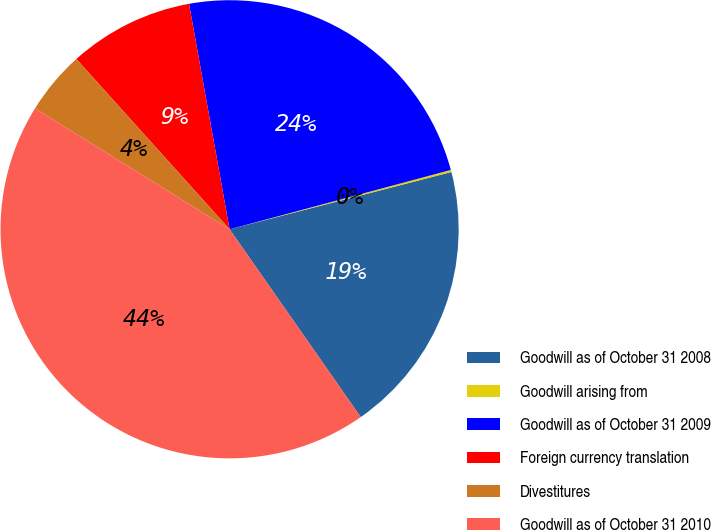Convert chart. <chart><loc_0><loc_0><loc_500><loc_500><pie_chart><fcel>Goodwill as of October 31 2008<fcel>Goodwill arising from<fcel>Goodwill as of October 31 2009<fcel>Foreign currency translation<fcel>Divestitures<fcel>Goodwill as of October 31 2010<nl><fcel>19.32%<fcel>0.15%<fcel>23.66%<fcel>8.83%<fcel>4.49%<fcel>43.55%<nl></chart> 